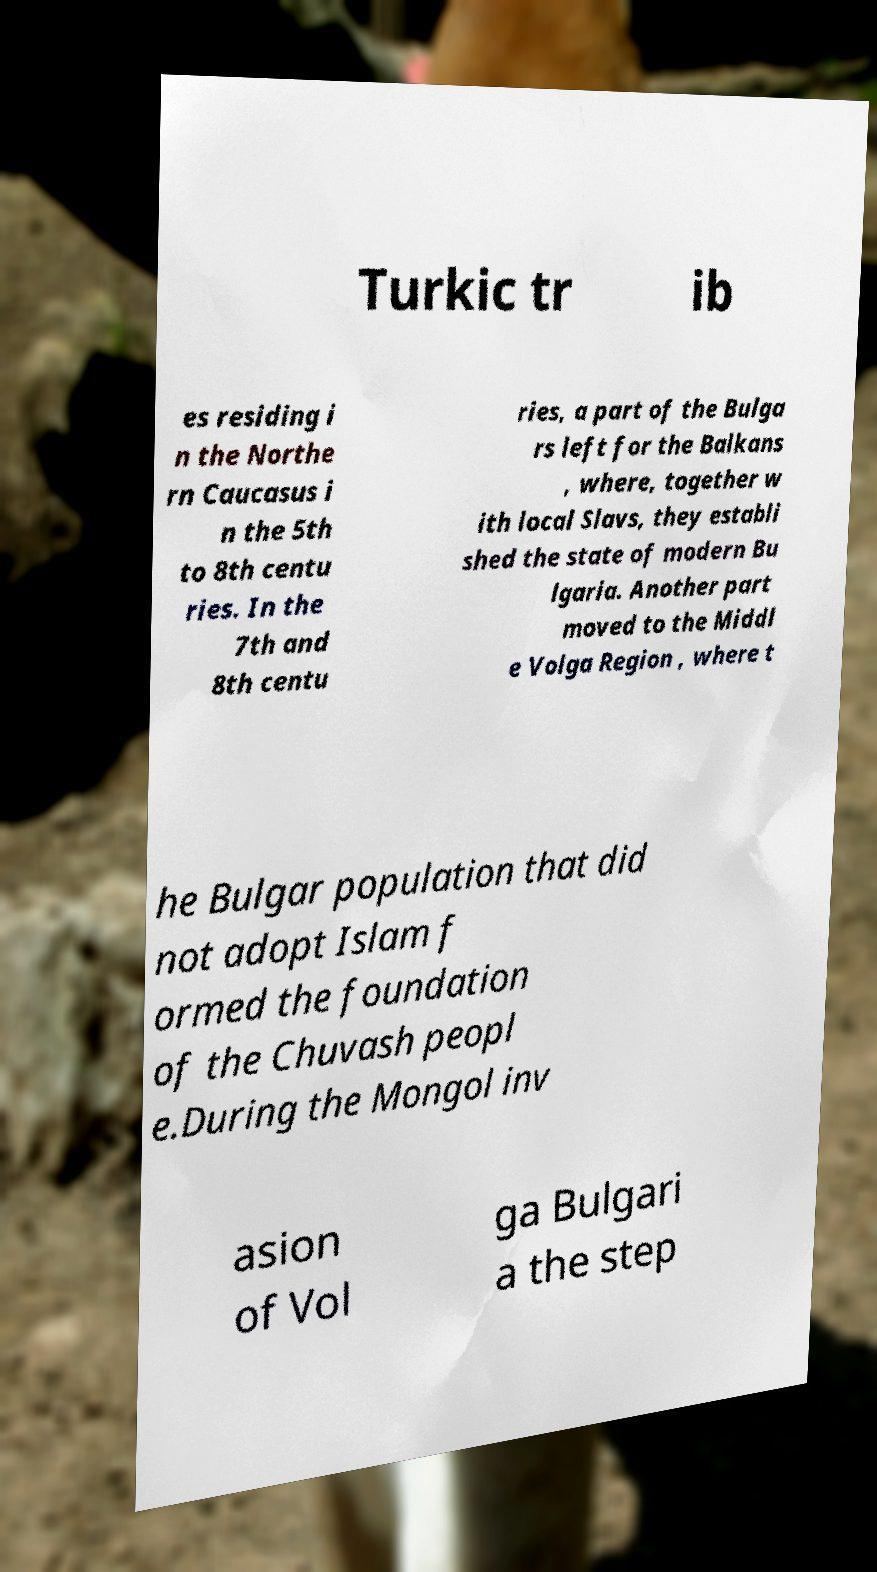What messages or text are displayed in this image? I need them in a readable, typed format. Turkic tr ib es residing i n the Northe rn Caucasus i n the 5th to 8th centu ries. In the 7th and 8th centu ries, a part of the Bulga rs left for the Balkans , where, together w ith local Slavs, they establi shed the state of modern Bu lgaria. Another part moved to the Middl e Volga Region , where t he Bulgar population that did not adopt Islam f ormed the foundation of the Chuvash peopl e.During the Mongol inv asion of Vol ga Bulgari a the step 